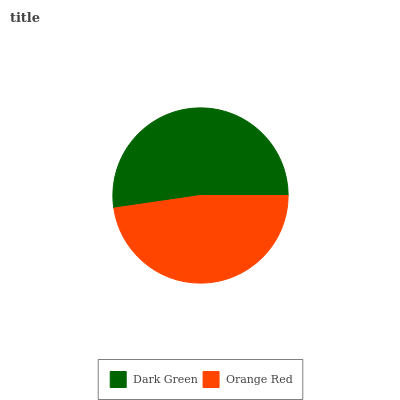Is Orange Red the minimum?
Answer yes or no. Yes. Is Dark Green the maximum?
Answer yes or no. Yes. Is Orange Red the maximum?
Answer yes or no. No. Is Dark Green greater than Orange Red?
Answer yes or no. Yes. Is Orange Red less than Dark Green?
Answer yes or no. Yes. Is Orange Red greater than Dark Green?
Answer yes or no. No. Is Dark Green less than Orange Red?
Answer yes or no. No. Is Dark Green the high median?
Answer yes or no. Yes. Is Orange Red the low median?
Answer yes or no. Yes. Is Orange Red the high median?
Answer yes or no. No. Is Dark Green the low median?
Answer yes or no. No. 